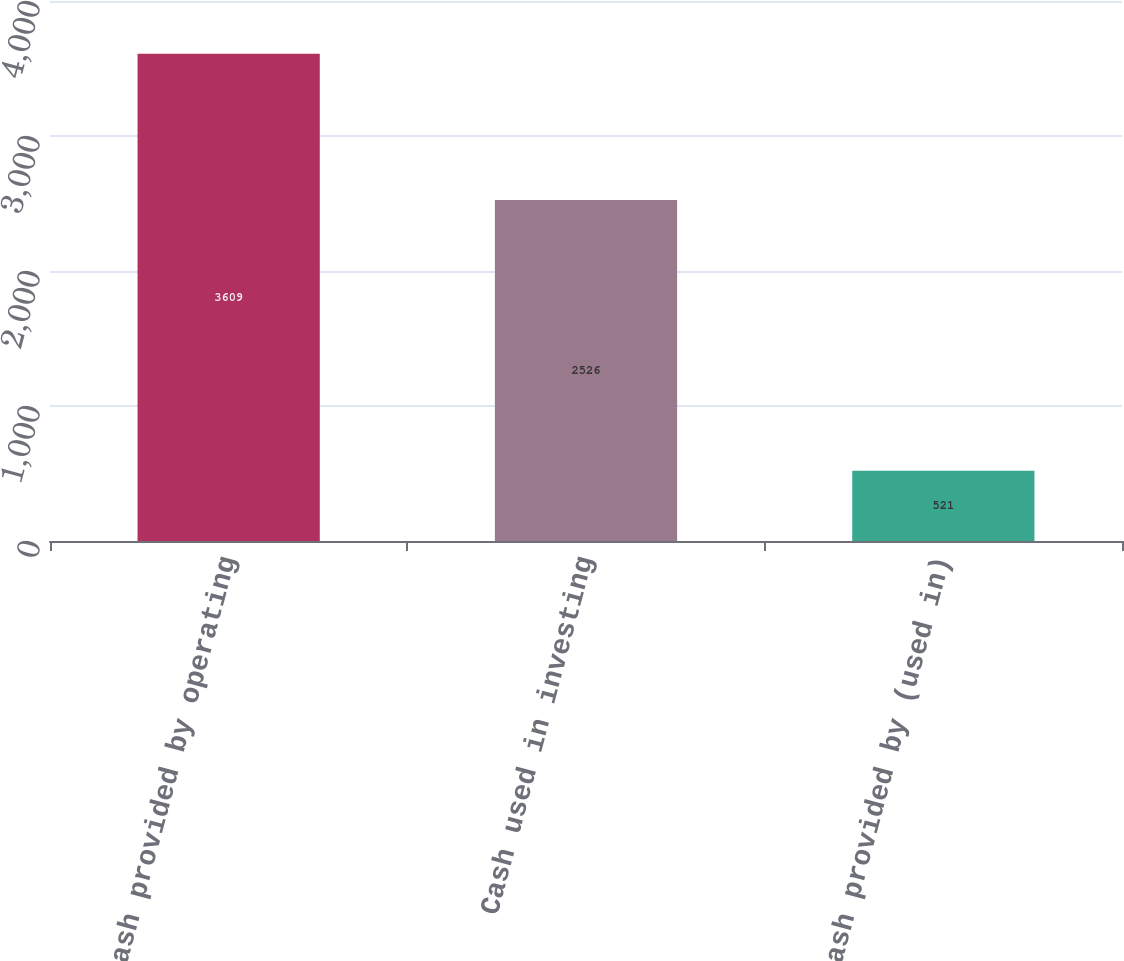<chart> <loc_0><loc_0><loc_500><loc_500><bar_chart><fcel>Cash provided by operating<fcel>Cash used in investing<fcel>Cash provided by (used in)<nl><fcel>3609<fcel>2526<fcel>521<nl></chart> 